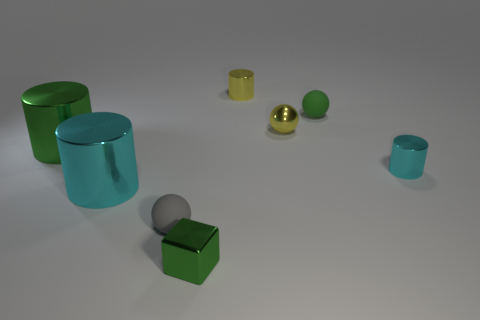Add 1 small cyan cylinders. How many objects exist? 9 Subtract all spheres. How many objects are left? 5 Subtract all spheres. Subtract all gray balls. How many objects are left? 4 Add 4 small cyan shiny objects. How many small cyan shiny objects are left? 5 Add 5 small metallic cylinders. How many small metallic cylinders exist? 7 Subtract 0 cyan cubes. How many objects are left? 8 